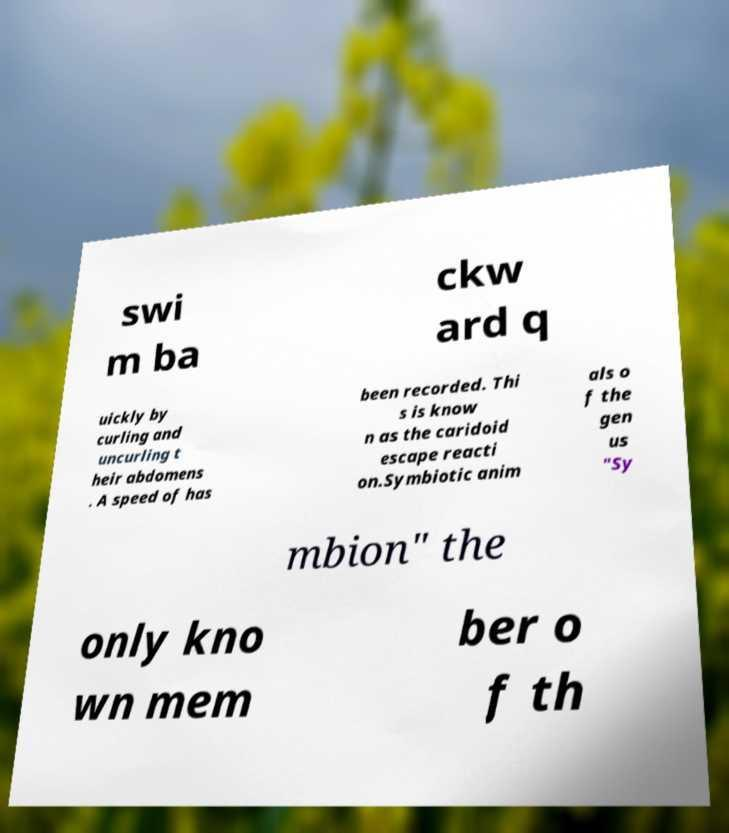Can you accurately transcribe the text from the provided image for me? swi m ba ckw ard q uickly by curling and uncurling t heir abdomens . A speed of has been recorded. Thi s is know n as the caridoid escape reacti on.Symbiotic anim als o f the gen us "Sy mbion" the only kno wn mem ber o f th 